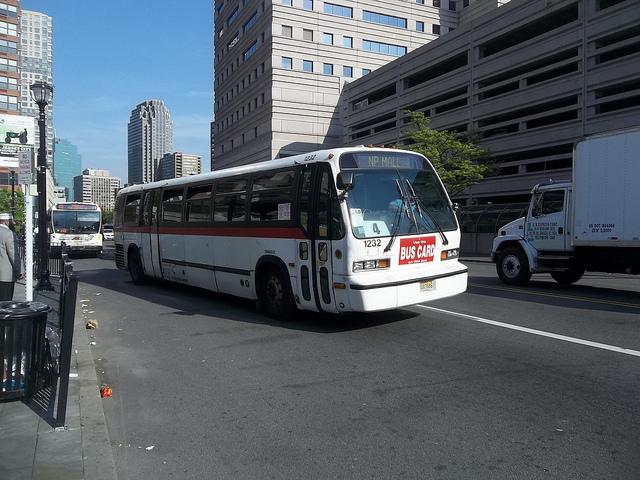What is the bus company's name?
Concise answer only. Bus card. Where are the traffic cones?
Write a very short answer. Bus. How many buses?
Quick response, please. 2. What is the front of the bus advertising?
Give a very brief answer. Bus card. Where is the bus at?
Keep it brief. Street. The color of the bus is white and what?
Quick response, please. Red. Is there litter?
Write a very short answer. Yes. 